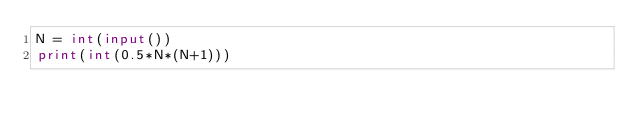Convert code to text. <code><loc_0><loc_0><loc_500><loc_500><_Python_>N = int(input())
print(int(0.5*N*(N+1)))</code> 